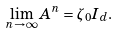Convert formula to latex. <formula><loc_0><loc_0><loc_500><loc_500>\lim _ { n \rightarrow \infty } A ^ { n } = \zeta _ { 0 } I _ { d } .</formula> 